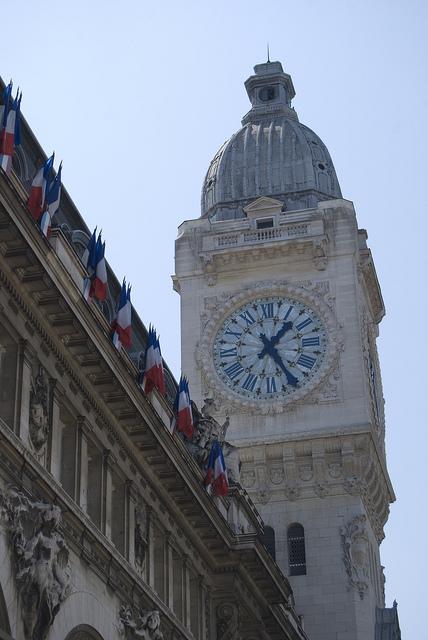What time is it?
Be succinct. 1:25. What are hanging at the top of the building?
Answer briefly. Flags. Is this a clock tower?
Concise answer only. Yes. 